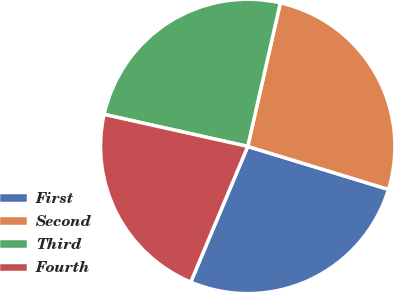Convert chart to OTSL. <chart><loc_0><loc_0><loc_500><loc_500><pie_chart><fcel>First<fcel>Second<fcel>Third<fcel>Fourth<nl><fcel>26.61%<fcel>26.17%<fcel>25.06%<fcel>22.16%<nl></chart> 